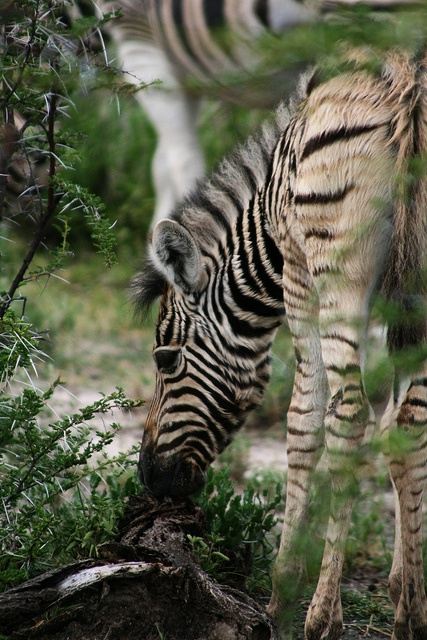Describe the objects in this image and their specific colors. I can see zebra in black, gray, and darkgray tones and zebra in black, gray, darkgreen, darkgray, and lightgray tones in this image. 